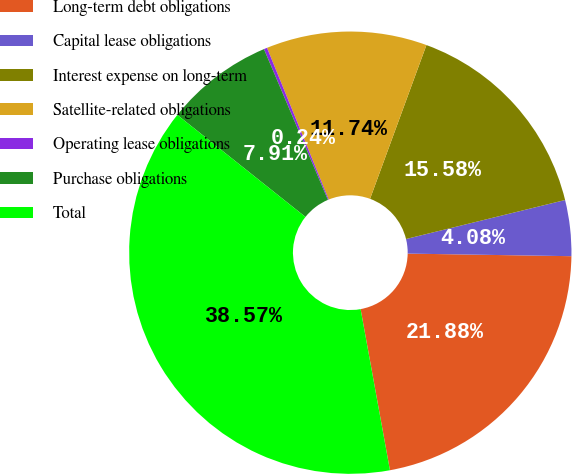<chart> <loc_0><loc_0><loc_500><loc_500><pie_chart><fcel>Long-term debt obligations<fcel>Capital lease obligations<fcel>Interest expense on long-term<fcel>Satellite-related obligations<fcel>Operating lease obligations<fcel>Purchase obligations<fcel>Total<nl><fcel>21.88%<fcel>4.08%<fcel>15.58%<fcel>11.74%<fcel>0.24%<fcel>7.91%<fcel>38.57%<nl></chart> 